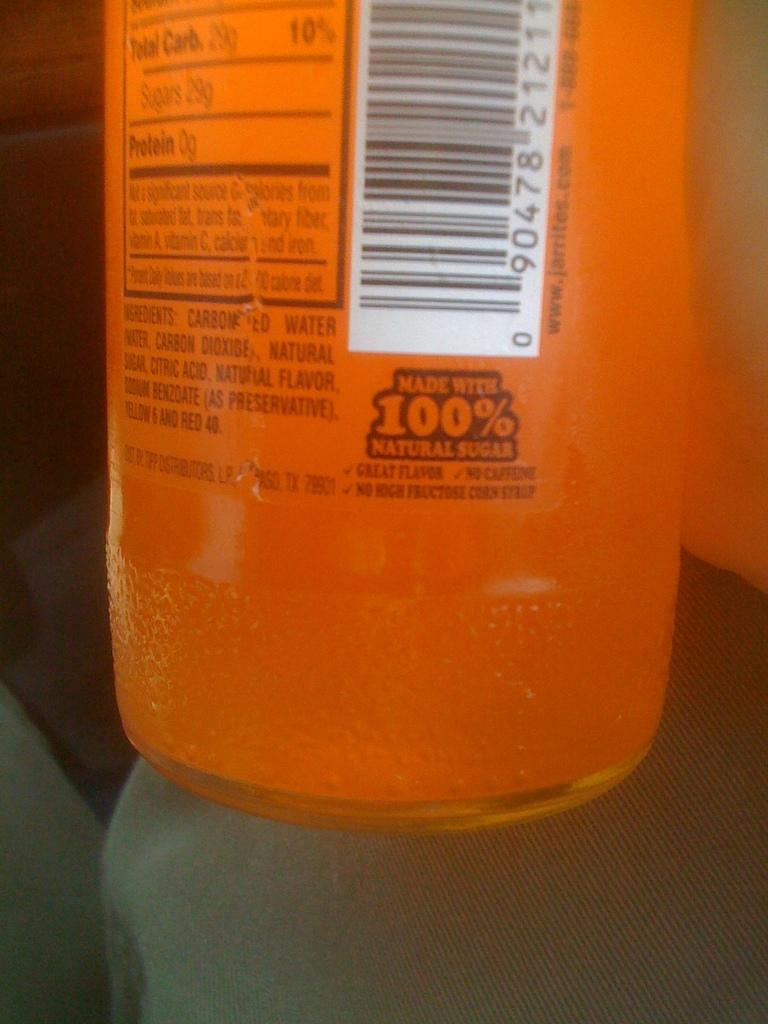What is this 100% of?
Make the answer very short. Natural sugar. How much protein is in this drink?
Your answer should be compact. 0g. 